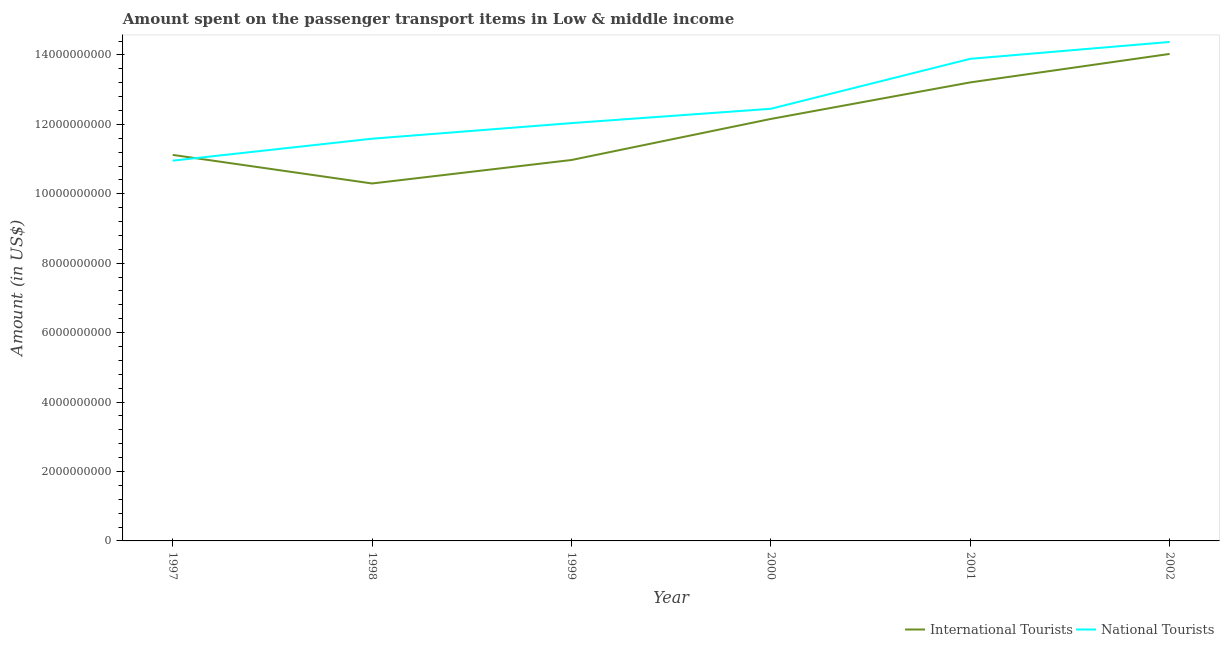How many different coloured lines are there?
Give a very brief answer. 2. Is the number of lines equal to the number of legend labels?
Provide a succinct answer. Yes. What is the amount spent on transport items of international tourists in 2001?
Your response must be concise. 1.32e+1. Across all years, what is the maximum amount spent on transport items of international tourists?
Offer a terse response. 1.40e+1. Across all years, what is the minimum amount spent on transport items of national tourists?
Offer a terse response. 1.10e+1. In which year was the amount spent on transport items of national tourists maximum?
Your answer should be very brief. 2002. What is the total amount spent on transport items of international tourists in the graph?
Keep it short and to the point. 7.18e+1. What is the difference between the amount spent on transport items of national tourists in 1997 and that in 1998?
Give a very brief answer. -6.33e+08. What is the difference between the amount spent on transport items of national tourists in 2002 and the amount spent on transport items of international tourists in 2000?
Keep it short and to the point. 2.22e+09. What is the average amount spent on transport items of national tourists per year?
Keep it short and to the point. 1.25e+1. In the year 2001, what is the difference between the amount spent on transport items of national tourists and amount spent on transport items of international tourists?
Make the answer very short. 6.79e+08. What is the ratio of the amount spent on transport items of national tourists in 1997 to that in 2002?
Give a very brief answer. 0.76. Is the difference between the amount spent on transport items of national tourists in 1997 and 2001 greater than the difference between the amount spent on transport items of international tourists in 1997 and 2001?
Your answer should be compact. No. What is the difference between the highest and the second highest amount spent on transport items of international tourists?
Offer a terse response. 8.20e+08. What is the difference between the highest and the lowest amount spent on transport items of international tourists?
Ensure brevity in your answer.  3.73e+09. Does the amount spent on transport items of international tourists monotonically increase over the years?
Your response must be concise. No. Is the amount spent on transport items of international tourists strictly less than the amount spent on transport items of national tourists over the years?
Your answer should be very brief. No. What is the difference between two consecutive major ticks on the Y-axis?
Provide a succinct answer. 2.00e+09. Where does the legend appear in the graph?
Your answer should be compact. Bottom right. What is the title of the graph?
Provide a short and direct response. Amount spent on the passenger transport items in Low & middle income. Does "Grants" appear as one of the legend labels in the graph?
Provide a short and direct response. No. What is the label or title of the X-axis?
Give a very brief answer. Year. What is the Amount (in US$) of International Tourists in 1997?
Your answer should be compact. 1.11e+1. What is the Amount (in US$) of National Tourists in 1997?
Ensure brevity in your answer.  1.10e+1. What is the Amount (in US$) in International Tourists in 1998?
Ensure brevity in your answer.  1.03e+1. What is the Amount (in US$) in National Tourists in 1998?
Offer a terse response. 1.16e+1. What is the Amount (in US$) in International Tourists in 1999?
Keep it short and to the point. 1.10e+1. What is the Amount (in US$) in National Tourists in 1999?
Your answer should be very brief. 1.20e+1. What is the Amount (in US$) in International Tourists in 2000?
Provide a short and direct response. 1.22e+1. What is the Amount (in US$) of National Tourists in 2000?
Offer a very short reply. 1.24e+1. What is the Amount (in US$) in International Tourists in 2001?
Offer a terse response. 1.32e+1. What is the Amount (in US$) in National Tourists in 2001?
Ensure brevity in your answer.  1.39e+1. What is the Amount (in US$) in International Tourists in 2002?
Your answer should be compact. 1.40e+1. What is the Amount (in US$) of National Tourists in 2002?
Offer a terse response. 1.44e+1. Across all years, what is the maximum Amount (in US$) in International Tourists?
Your answer should be compact. 1.40e+1. Across all years, what is the maximum Amount (in US$) in National Tourists?
Offer a very short reply. 1.44e+1. Across all years, what is the minimum Amount (in US$) of International Tourists?
Your answer should be compact. 1.03e+1. Across all years, what is the minimum Amount (in US$) in National Tourists?
Provide a short and direct response. 1.10e+1. What is the total Amount (in US$) of International Tourists in the graph?
Your response must be concise. 7.18e+1. What is the total Amount (in US$) of National Tourists in the graph?
Offer a terse response. 7.53e+1. What is the difference between the Amount (in US$) in International Tourists in 1997 and that in 1998?
Keep it short and to the point. 8.24e+08. What is the difference between the Amount (in US$) of National Tourists in 1997 and that in 1998?
Provide a succinct answer. -6.33e+08. What is the difference between the Amount (in US$) in International Tourists in 1997 and that in 1999?
Make the answer very short. 1.47e+08. What is the difference between the Amount (in US$) in National Tourists in 1997 and that in 1999?
Your answer should be compact. -1.08e+09. What is the difference between the Amount (in US$) of International Tourists in 1997 and that in 2000?
Provide a short and direct response. -1.04e+09. What is the difference between the Amount (in US$) of National Tourists in 1997 and that in 2000?
Give a very brief answer. -1.49e+09. What is the difference between the Amount (in US$) of International Tourists in 1997 and that in 2001?
Provide a succinct answer. -2.09e+09. What is the difference between the Amount (in US$) of National Tourists in 1997 and that in 2001?
Provide a short and direct response. -2.93e+09. What is the difference between the Amount (in US$) in International Tourists in 1997 and that in 2002?
Your response must be concise. -2.91e+09. What is the difference between the Amount (in US$) in National Tourists in 1997 and that in 2002?
Keep it short and to the point. -3.42e+09. What is the difference between the Amount (in US$) of International Tourists in 1998 and that in 1999?
Give a very brief answer. -6.76e+08. What is the difference between the Amount (in US$) of National Tourists in 1998 and that in 1999?
Offer a terse response. -4.49e+08. What is the difference between the Amount (in US$) of International Tourists in 1998 and that in 2000?
Your answer should be very brief. -1.86e+09. What is the difference between the Amount (in US$) of National Tourists in 1998 and that in 2000?
Offer a terse response. -8.62e+08. What is the difference between the Amount (in US$) in International Tourists in 1998 and that in 2001?
Make the answer very short. -2.91e+09. What is the difference between the Amount (in US$) of National Tourists in 1998 and that in 2001?
Provide a short and direct response. -2.30e+09. What is the difference between the Amount (in US$) in International Tourists in 1998 and that in 2002?
Provide a succinct answer. -3.73e+09. What is the difference between the Amount (in US$) of National Tourists in 1998 and that in 2002?
Provide a short and direct response. -2.79e+09. What is the difference between the Amount (in US$) of International Tourists in 1999 and that in 2000?
Provide a succinct answer. -1.18e+09. What is the difference between the Amount (in US$) in National Tourists in 1999 and that in 2000?
Keep it short and to the point. -4.13e+08. What is the difference between the Amount (in US$) in International Tourists in 1999 and that in 2001?
Keep it short and to the point. -2.24e+09. What is the difference between the Amount (in US$) of National Tourists in 1999 and that in 2001?
Provide a short and direct response. -1.85e+09. What is the difference between the Amount (in US$) of International Tourists in 1999 and that in 2002?
Provide a short and direct response. -3.06e+09. What is the difference between the Amount (in US$) of National Tourists in 1999 and that in 2002?
Your response must be concise. -2.34e+09. What is the difference between the Amount (in US$) in International Tourists in 2000 and that in 2001?
Make the answer very short. -1.05e+09. What is the difference between the Amount (in US$) in National Tourists in 2000 and that in 2001?
Your answer should be very brief. -1.44e+09. What is the difference between the Amount (in US$) in International Tourists in 2000 and that in 2002?
Provide a succinct answer. -1.87e+09. What is the difference between the Amount (in US$) in National Tourists in 2000 and that in 2002?
Make the answer very short. -1.93e+09. What is the difference between the Amount (in US$) of International Tourists in 2001 and that in 2002?
Make the answer very short. -8.20e+08. What is the difference between the Amount (in US$) in National Tourists in 2001 and that in 2002?
Make the answer very short. -4.86e+08. What is the difference between the Amount (in US$) in International Tourists in 1997 and the Amount (in US$) in National Tourists in 1998?
Provide a short and direct response. -4.66e+08. What is the difference between the Amount (in US$) of International Tourists in 1997 and the Amount (in US$) of National Tourists in 1999?
Your response must be concise. -9.15e+08. What is the difference between the Amount (in US$) of International Tourists in 1997 and the Amount (in US$) of National Tourists in 2000?
Your response must be concise. -1.33e+09. What is the difference between the Amount (in US$) of International Tourists in 1997 and the Amount (in US$) of National Tourists in 2001?
Your answer should be compact. -2.77e+09. What is the difference between the Amount (in US$) of International Tourists in 1997 and the Amount (in US$) of National Tourists in 2002?
Your answer should be compact. -3.25e+09. What is the difference between the Amount (in US$) in International Tourists in 1998 and the Amount (in US$) in National Tourists in 1999?
Give a very brief answer. -1.74e+09. What is the difference between the Amount (in US$) of International Tourists in 1998 and the Amount (in US$) of National Tourists in 2000?
Your answer should be compact. -2.15e+09. What is the difference between the Amount (in US$) in International Tourists in 1998 and the Amount (in US$) in National Tourists in 2001?
Provide a succinct answer. -3.59e+09. What is the difference between the Amount (in US$) in International Tourists in 1998 and the Amount (in US$) in National Tourists in 2002?
Offer a terse response. -4.08e+09. What is the difference between the Amount (in US$) in International Tourists in 1999 and the Amount (in US$) in National Tourists in 2000?
Your answer should be compact. -1.48e+09. What is the difference between the Amount (in US$) in International Tourists in 1999 and the Amount (in US$) in National Tourists in 2001?
Provide a succinct answer. -2.91e+09. What is the difference between the Amount (in US$) in International Tourists in 1999 and the Amount (in US$) in National Tourists in 2002?
Provide a short and direct response. -3.40e+09. What is the difference between the Amount (in US$) in International Tourists in 2000 and the Amount (in US$) in National Tourists in 2001?
Provide a short and direct response. -1.73e+09. What is the difference between the Amount (in US$) in International Tourists in 2000 and the Amount (in US$) in National Tourists in 2002?
Ensure brevity in your answer.  -2.22e+09. What is the difference between the Amount (in US$) of International Tourists in 2001 and the Amount (in US$) of National Tourists in 2002?
Make the answer very short. -1.17e+09. What is the average Amount (in US$) in International Tourists per year?
Offer a terse response. 1.20e+1. What is the average Amount (in US$) of National Tourists per year?
Your answer should be very brief. 1.25e+1. In the year 1997, what is the difference between the Amount (in US$) of International Tourists and Amount (in US$) of National Tourists?
Make the answer very short. 1.67e+08. In the year 1998, what is the difference between the Amount (in US$) of International Tourists and Amount (in US$) of National Tourists?
Keep it short and to the point. -1.29e+09. In the year 1999, what is the difference between the Amount (in US$) of International Tourists and Amount (in US$) of National Tourists?
Your answer should be very brief. -1.06e+09. In the year 2000, what is the difference between the Amount (in US$) in International Tourists and Amount (in US$) in National Tourists?
Give a very brief answer. -2.92e+08. In the year 2001, what is the difference between the Amount (in US$) in International Tourists and Amount (in US$) in National Tourists?
Ensure brevity in your answer.  -6.79e+08. In the year 2002, what is the difference between the Amount (in US$) of International Tourists and Amount (in US$) of National Tourists?
Keep it short and to the point. -3.45e+08. What is the ratio of the Amount (in US$) of National Tourists in 1997 to that in 1998?
Provide a succinct answer. 0.95. What is the ratio of the Amount (in US$) in International Tourists in 1997 to that in 1999?
Provide a short and direct response. 1.01. What is the ratio of the Amount (in US$) of National Tourists in 1997 to that in 1999?
Your answer should be very brief. 0.91. What is the ratio of the Amount (in US$) of International Tourists in 1997 to that in 2000?
Your response must be concise. 0.91. What is the ratio of the Amount (in US$) of National Tourists in 1997 to that in 2000?
Keep it short and to the point. 0.88. What is the ratio of the Amount (in US$) in International Tourists in 1997 to that in 2001?
Give a very brief answer. 0.84. What is the ratio of the Amount (in US$) in National Tourists in 1997 to that in 2001?
Ensure brevity in your answer.  0.79. What is the ratio of the Amount (in US$) of International Tourists in 1997 to that in 2002?
Your answer should be compact. 0.79. What is the ratio of the Amount (in US$) in National Tourists in 1997 to that in 2002?
Give a very brief answer. 0.76. What is the ratio of the Amount (in US$) of International Tourists in 1998 to that in 1999?
Provide a succinct answer. 0.94. What is the ratio of the Amount (in US$) in National Tourists in 1998 to that in 1999?
Your answer should be very brief. 0.96. What is the ratio of the Amount (in US$) of International Tourists in 1998 to that in 2000?
Make the answer very short. 0.85. What is the ratio of the Amount (in US$) of National Tourists in 1998 to that in 2000?
Provide a succinct answer. 0.93. What is the ratio of the Amount (in US$) of International Tourists in 1998 to that in 2001?
Give a very brief answer. 0.78. What is the ratio of the Amount (in US$) of National Tourists in 1998 to that in 2001?
Ensure brevity in your answer.  0.83. What is the ratio of the Amount (in US$) of International Tourists in 1998 to that in 2002?
Offer a very short reply. 0.73. What is the ratio of the Amount (in US$) of National Tourists in 1998 to that in 2002?
Your answer should be compact. 0.81. What is the ratio of the Amount (in US$) of International Tourists in 1999 to that in 2000?
Your response must be concise. 0.9. What is the ratio of the Amount (in US$) of National Tourists in 1999 to that in 2000?
Make the answer very short. 0.97. What is the ratio of the Amount (in US$) of International Tourists in 1999 to that in 2001?
Your answer should be very brief. 0.83. What is the ratio of the Amount (in US$) of National Tourists in 1999 to that in 2001?
Your answer should be compact. 0.87. What is the ratio of the Amount (in US$) of International Tourists in 1999 to that in 2002?
Your answer should be compact. 0.78. What is the ratio of the Amount (in US$) of National Tourists in 1999 to that in 2002?
Provide a short and direct response. 0.84. What is the ratio of the Amount (in US$) in International Tourists in 2000 to that in 2001?
Provide a succinct answer. 0.92. What is the ratio of the Amount (in US$) in National Tourists in 2000 to that in 2001?
Your answer should be very brief. 0.9. What is the ratio of the Amount (in US$) in International Tourists in 2000 to that in 2002?
Ensure brevity in your answer.  0.87. What is the ratio of the Amount (in US$) of National Tourists in 2000 to that in 2002?
Your answer should be very brief. 0.87. What is the ratio of the Amount (in US$) in International Tourists in 2001 to that in 2002?
Offer a terse response. 0.94. What is the ratio of the Amount (in US$) in National Tourists in 2001 to that in 2002?
Give a very brief answer. 0.97. What is the difference between the highest and the second highest Amount (in US$) of International Tourists?
Your response must be concise. 8.20e+08. What is the difference between the highest and the second highest Amount (in US$) in National Tourists?
Provide a succinct answer. 4.86e+08. What is the difference between the highest and the lowest Amount (in US$) of International Tourists?
Offer a terse response. 3.73e+09. What is the difference between the highest and the lowest Amount (in US$) in National Tourists?
Your answer should be very brief. 3.42e+09. 